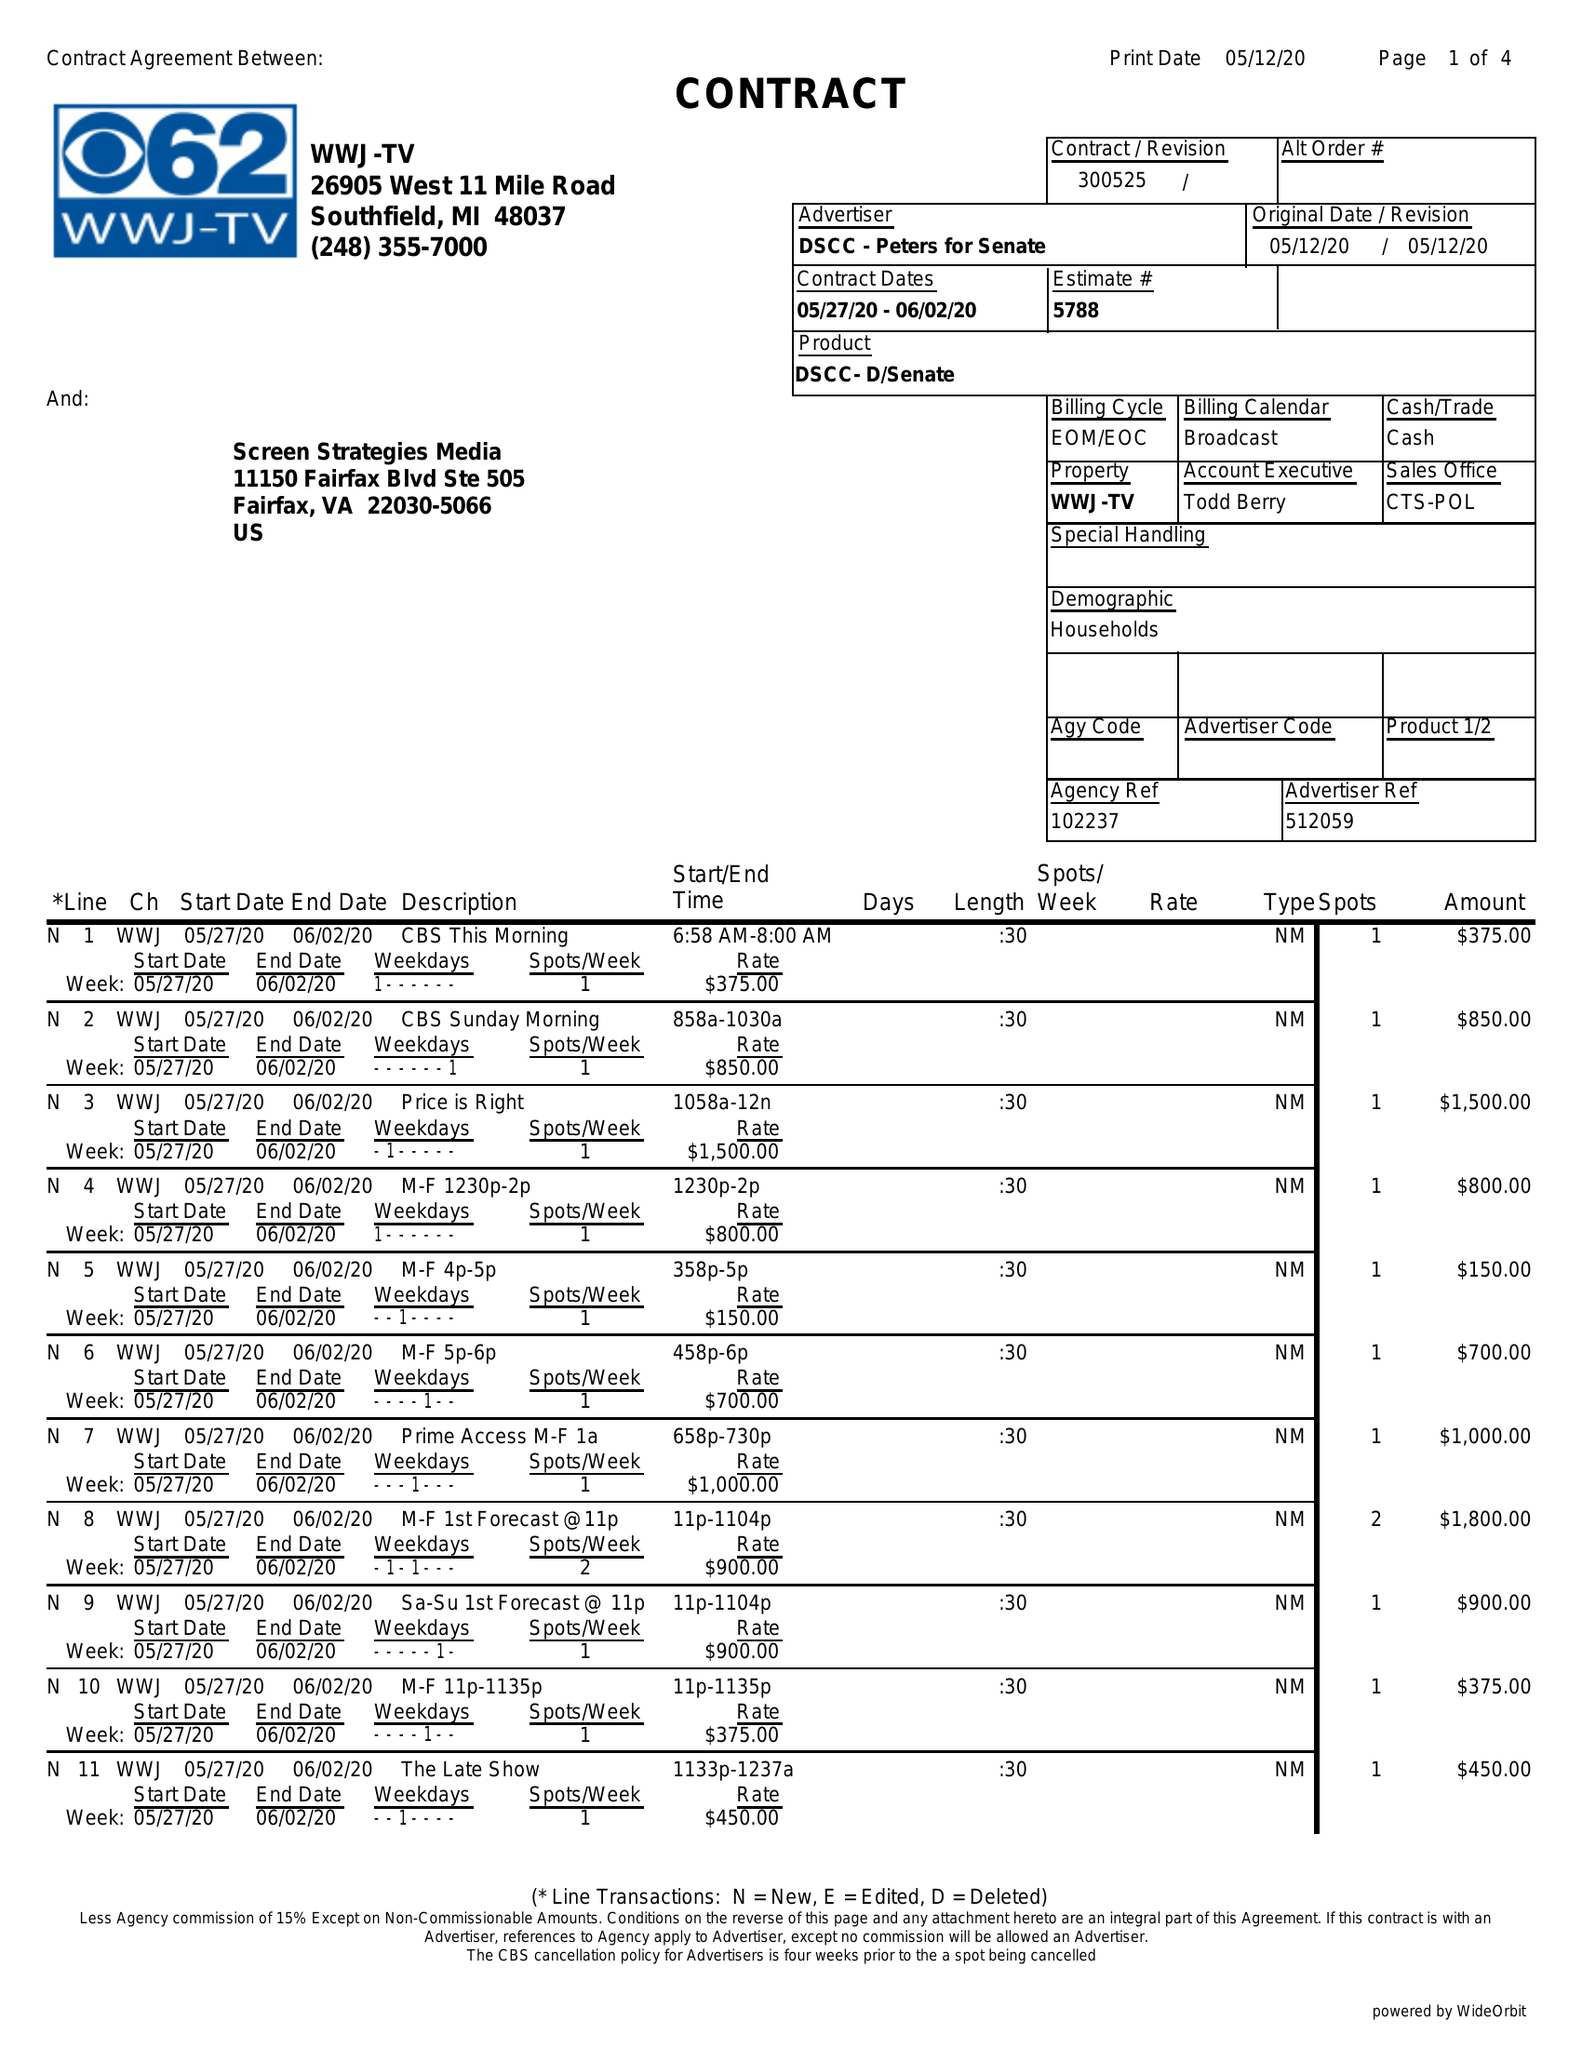What is the value for the flight_to?
Answer the question using a single word or phrase. 06/02/20 